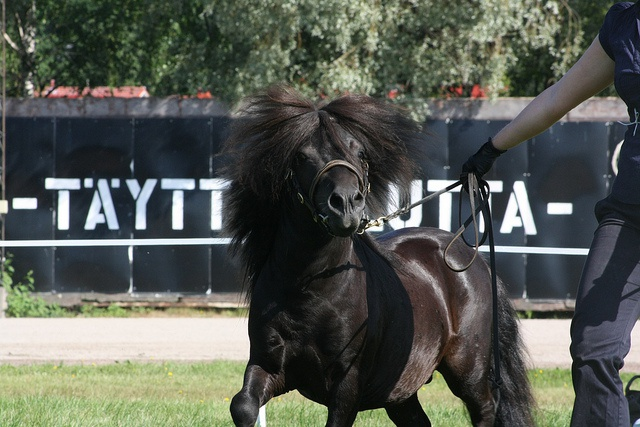Describe the objects in this image and their specific colors. I can see horse in gray, black, and darkgray tones and people in gray and black tones in this image. 